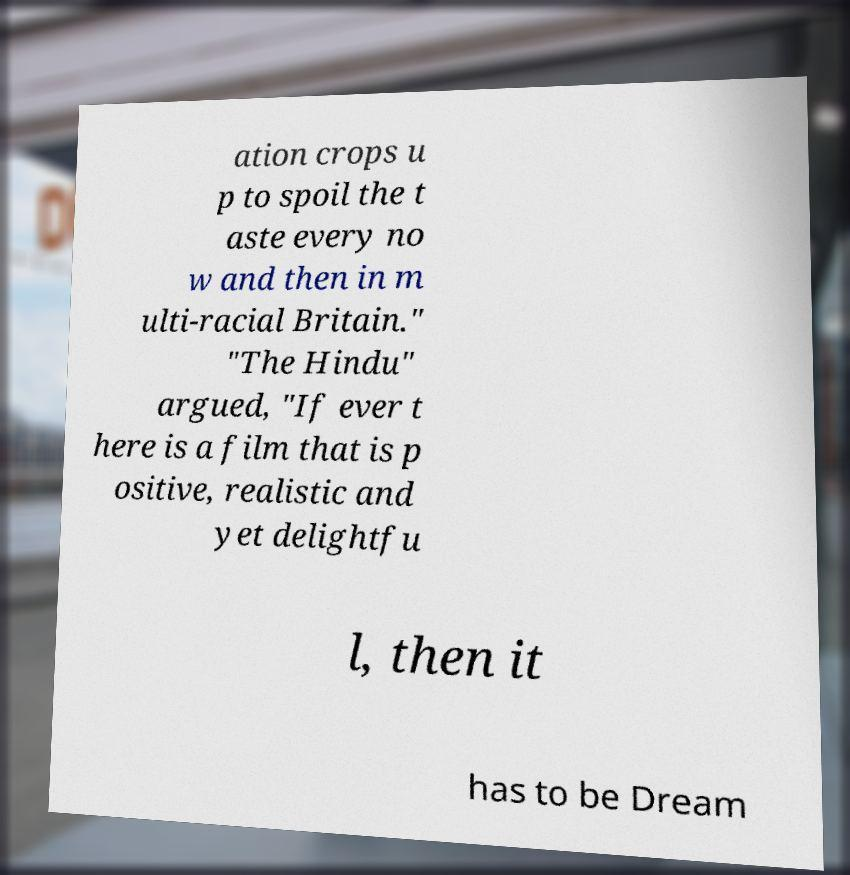For documentation purposes, I need the text within this image transcribed. Could you provide that? ation crops u p to spoil the t aste every no w and then in m ulti-racial Britain." "The Hindu" argued, "If ever t here is a film that is p ositive, realistic and yet delightfu l, then it has to be Dream 